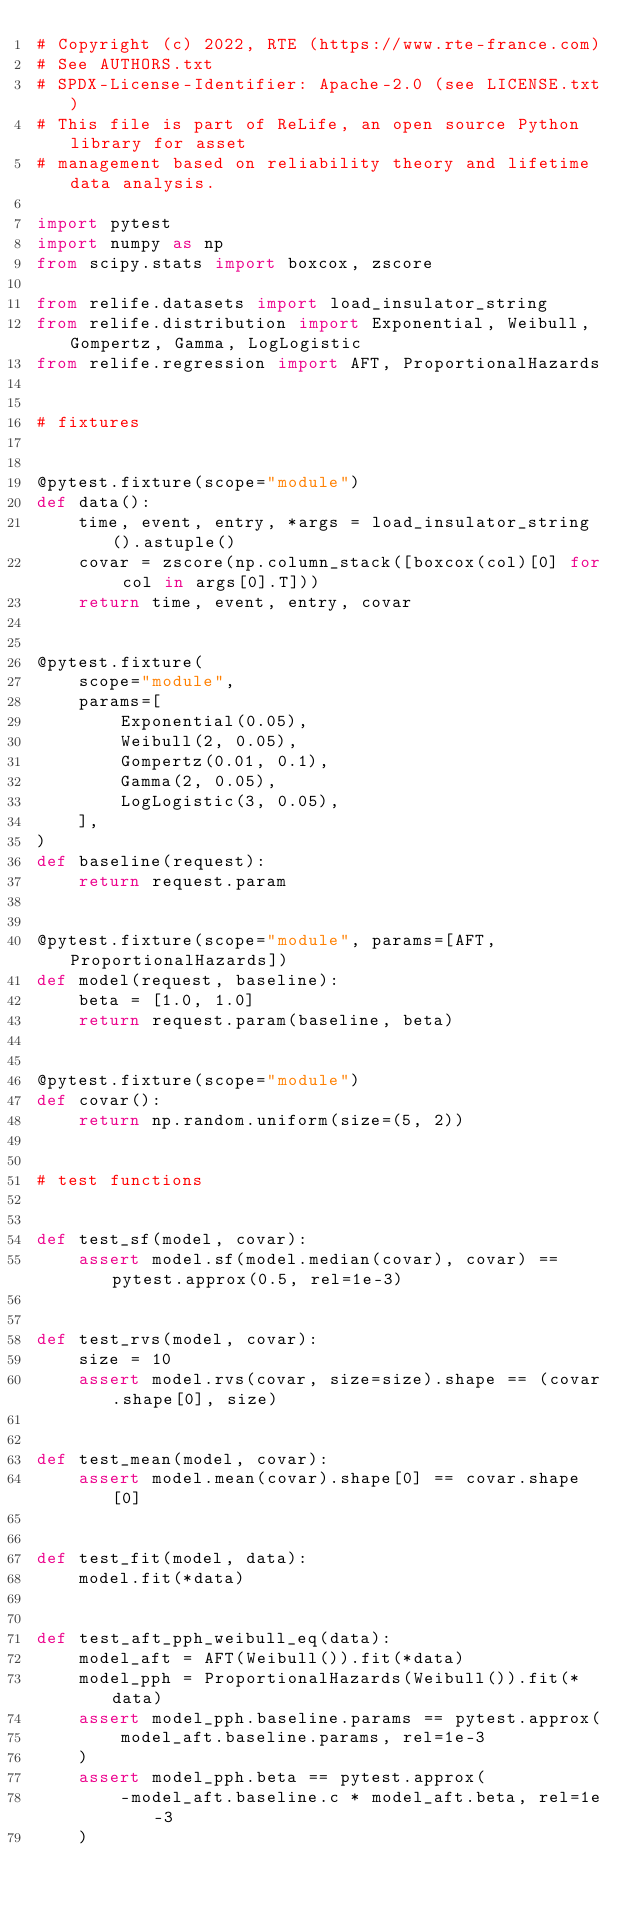<code> <loc_0><loc_0><loc_500><loc_500><_Python_># Copyright (c) 2022, RTE (https://www.rte-france.com)
# See AUTHORS.txt
# SPDX-License-Identifier: Apache-2.0 (see LICENSE.txt)
# This file is part of ReLife, an open source Python library for asset
# management based on reliability theory and lifetime data analysis.

import pytest
import numpy as np
from scipy.stats import boxcox, zscore

from relife.datasets import load_insulator_string
from relife.distribution import Exponential, Weibull, Gompertz, Gamma, LogLogistic
from relife.regression import AFT, ProportionalHazards


# fixtures


@pytest.fixture(scope="module")
def data():
    time, event, entry, *args = load_insulator_string().astuple()
    covar = zscore(np.column_stack([boxcox(col)[0] for col in args[0].T]))
    return time, event, entry, covar


@pytest.fixture(
    scope="module",
    params=[
        Exponential(0.05),
        Weibull(2, 0.05),
        Gompertz(0.01, 0.1),
        Gamma(2, 0.05),
        LogLogistic(3, 0.05),
    ],
)
def baseline(request):
    return request.param


@pytest.fixture(scope="module", params=[AFT, ProportionalHazards])
def model(request, baseline):
    beta = [1.0, 1.0]
    return request.param(baseline, beta)


@pytest.fixture(scope="module")
def covar():
    return np.random.uniform(size=(5, 2))


# test functions


def test_sf(model, covar):
    assert model.sf(model.median(covar), covar) == pytest.approx(0.5, rel=1e-3)


def test_rvs(model, covar):
    size = 10
    assert model.rvs(covar, size=size).shape == (covar.shape[0], size)


def test_mean(model, covar):
    assert model.mean(covar).shape[0] == covar.shape[0]


def test_fit(model, data):
    model.fit(*data)


def test_aft_pph_weibull_eq(data):
    model_aft = AFT(Weibull()).fit(*data)
    model_pph = ProportionalHazards(Weibull()).fit(*data)
    assert model_pph.baseline.params == pytest.approx(
        model_aft.baseline.params, rel=1e-3
    )
    assert model_pph.beta == pytest.approx(
        -model_aft.baseline.c * model_aft.beta, rel=1e-3
    )
</code> 